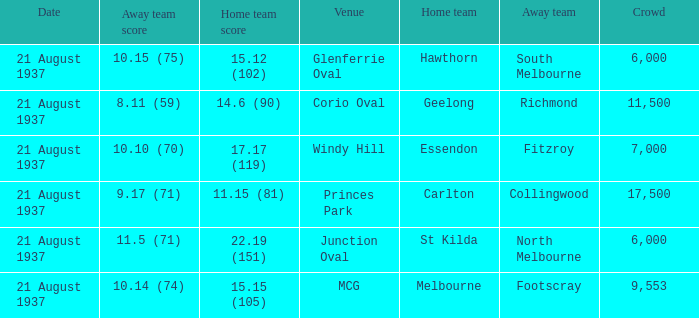Where does South Melbourne play? Glenferrie Oval. 